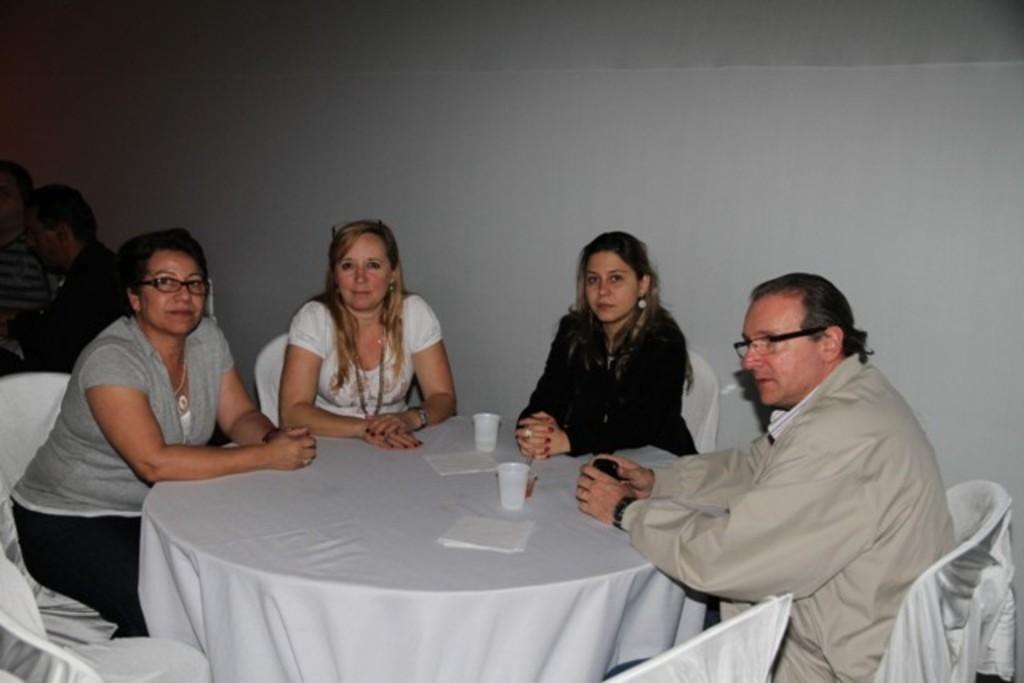Could you give a brief overview of what you see in this image? On the background this is a white color wall. Here we can see few persons sitting on the chairs in front of a table and on the table we can see tissue papers and white colour glasses. 